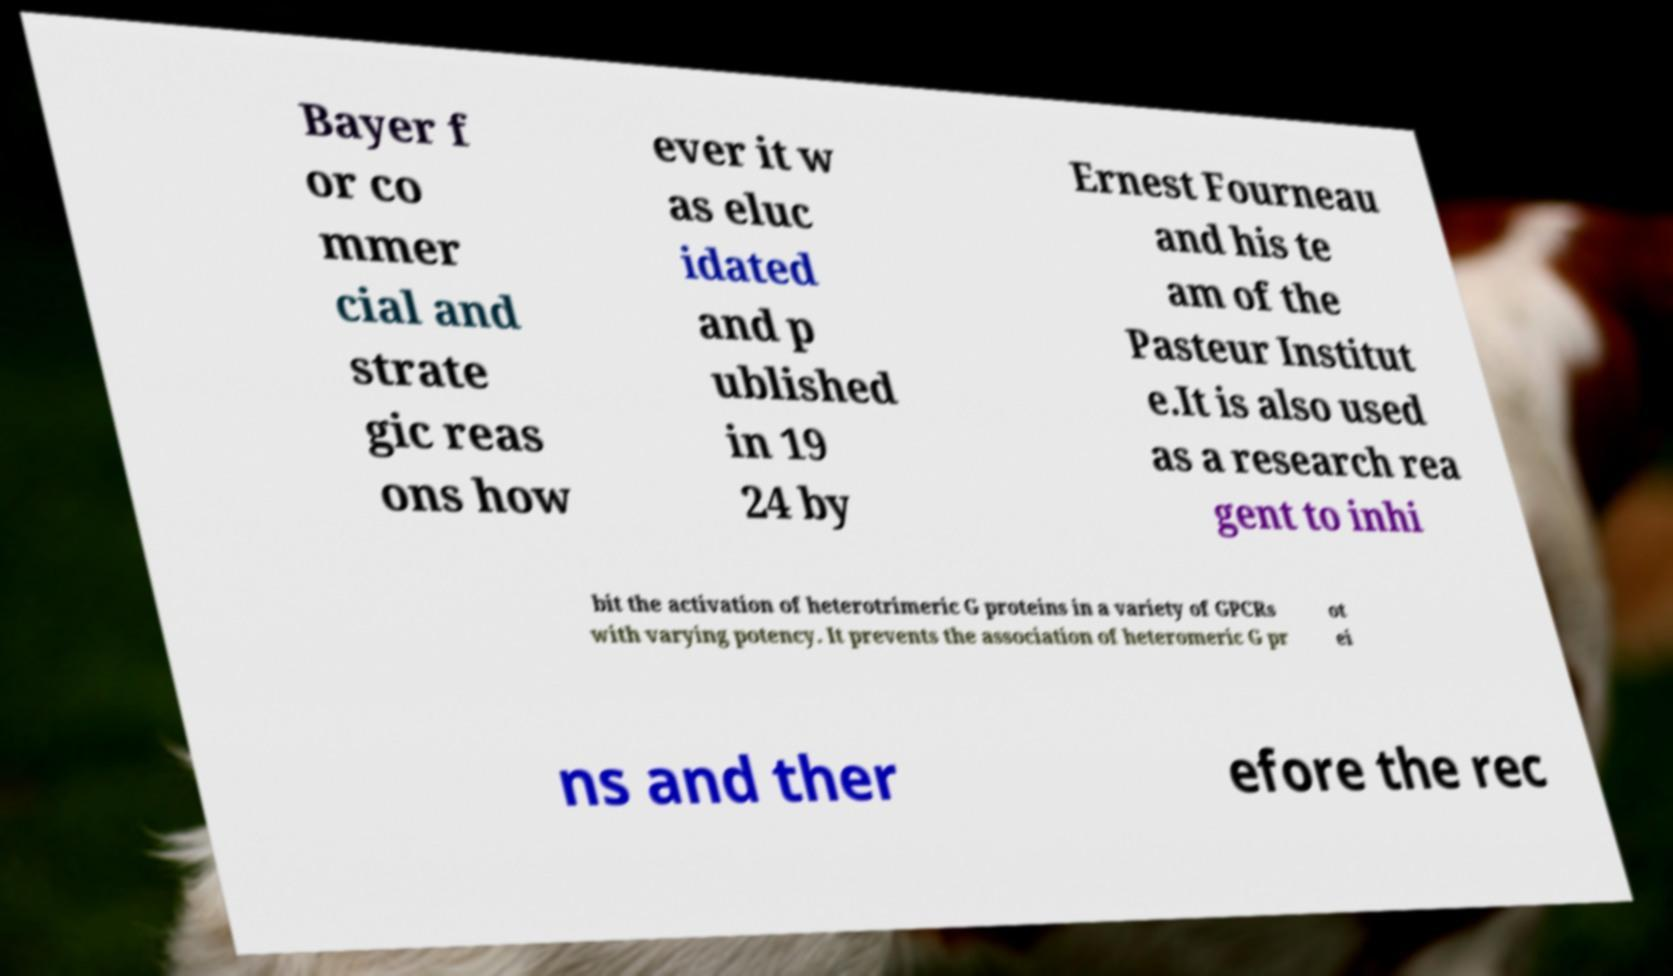Please identify and transcribe the text found in this image. Bayer f or co mmer cial and strate gic reas ons how ever it w as eluc idated and p ublished in 19 24 by Ernest Fourneau and his te am of the Pasteur Institut e.It is also used as a research rea gent to inhi bit the activation of heterotrimeric G proteins in a variety of GPCRs with varying potency. It prevents the association of heteromeric G pr ot ei ns and ther efore the rec 